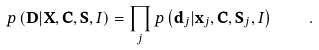<formula> <loc_0><loc_0><loc_500><loc_500>p \left ( \mathbf D | \mathbf X , \mathbf C , \mathbf S , I \right ) = \prod _ { j } p \left ( \mathbf d _ { j } | \mathbf x _ { j } , \mathbf C , \mathbf S _ { j } , I \right ) \quad .</formula> 